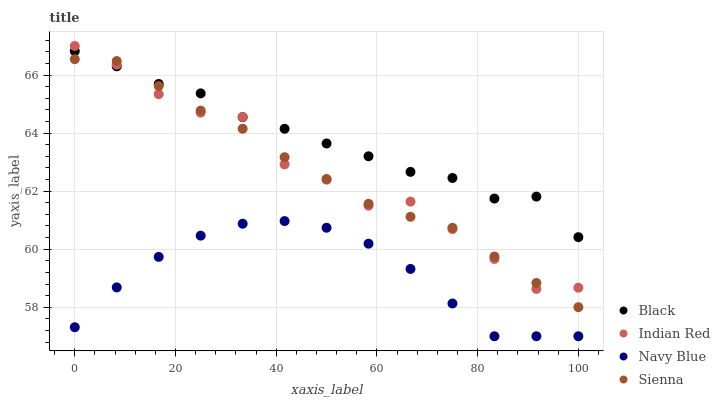Does Navy Blue have the minimum area under the curve?
Answer yes or no. Yes. Does Black have the maximum area under the curve?
Answer yes or no. Yes. Does Black have the minimum area under the curve?
Answer yes or no. No. Does Navy Blue have the maximum area under the curve?
Answer yes or no. No. Is Sienna the smoothest?
Answer yes or no. Yes. Is Indian Red the roughest?
Answer yes or no. Yes. Is Navy Blue the smoothest?
Answer yes or no. No. Is Navy Blue the roughest?
Answer yes or no. No. Does Navy Blue have the lowest value?
Answer yes or no. Yes. Does Black have the lowest value?
Answer yes or no. No. Does Indian Red have the highest value?
Answer yes or no. Yes. Does Black have the highest value?
Answer yes or no. No. Is Navy Blue less than Indian Red?
Answer yes or no. Yes. Is Black greater than Navy Blue?
Answer yes or no. Yes. Does Black intersect Indian Red?
Answer yes or no. Yes. Is Black less than Indian Red?
Answer yes or no. No. Is Black greater than Indian Red?
Answer yes or no. No. Does Navy Blue intersect Indian Red?
Answer yes or no. No. 